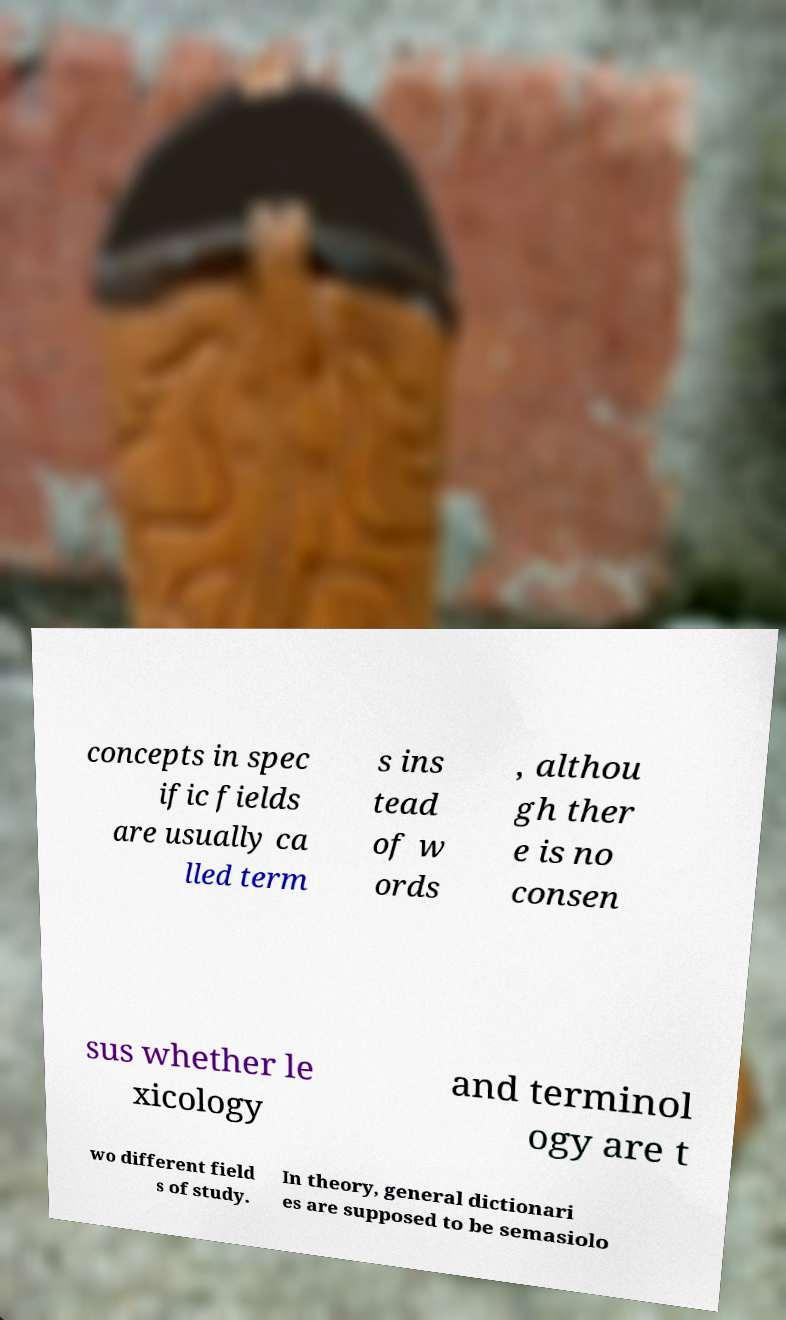Please identify and transcribe the text found in this image. concepts in spec ific fields are usually ca lled term s ins tead of w ords , althou gh ther e is no consen sus whether le xicology and terminol ogy are t wo different field s of study. In theory, general dictionari es are supposed to be semasiolo 